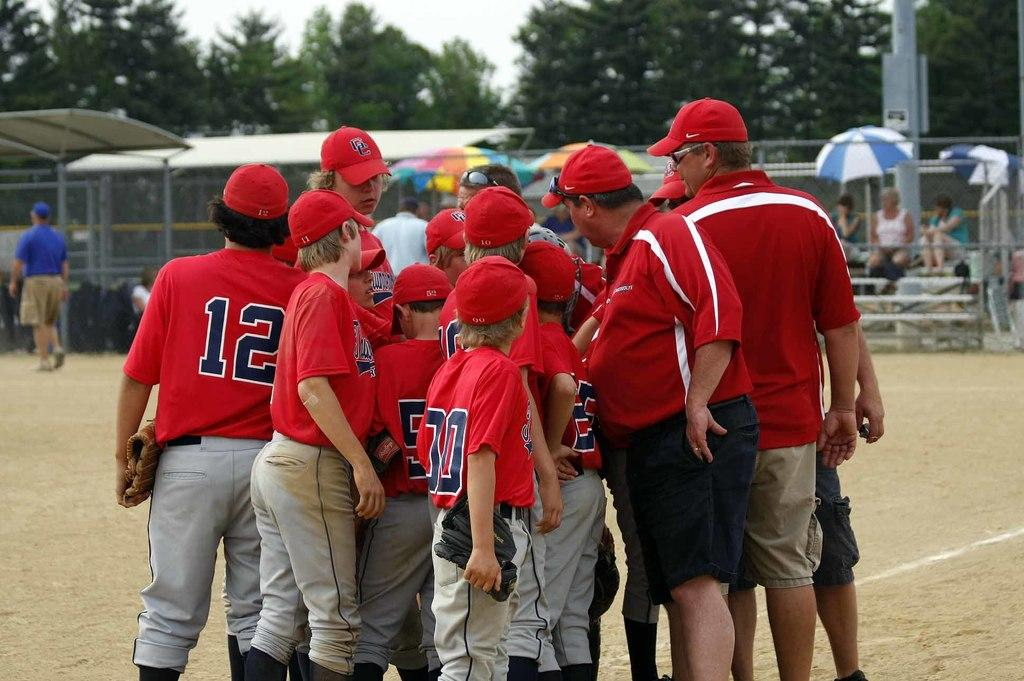<image>
Create a compact narrative representing the image presented. A baseball player with the number 12 on his jersey with a group of other baseball players. 